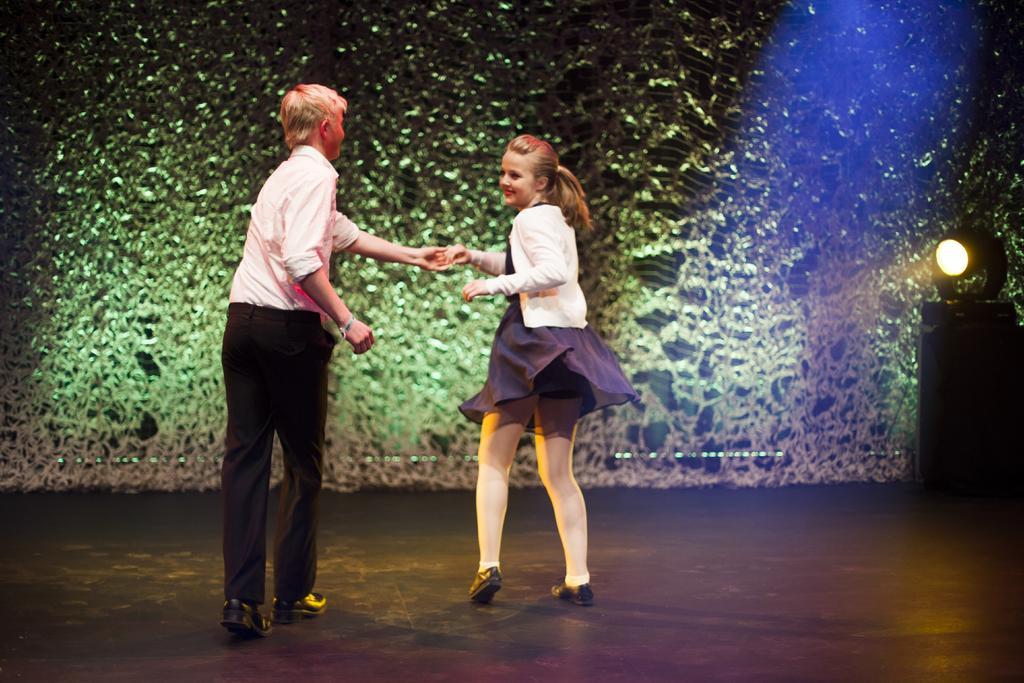Please provide a concise description of this image. In this image we can see one light on the surface, two persons dancing on a stage and backside of these persons one big green color wall is there. 